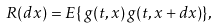Convert formula to latex. <formula><loc_0><loc_0><loc_500><loc_500>R ( d { x } ) = E \{ \, g ( t , { x } ) \, g ( t , { x } + d { x } ) \} ,</formula> 